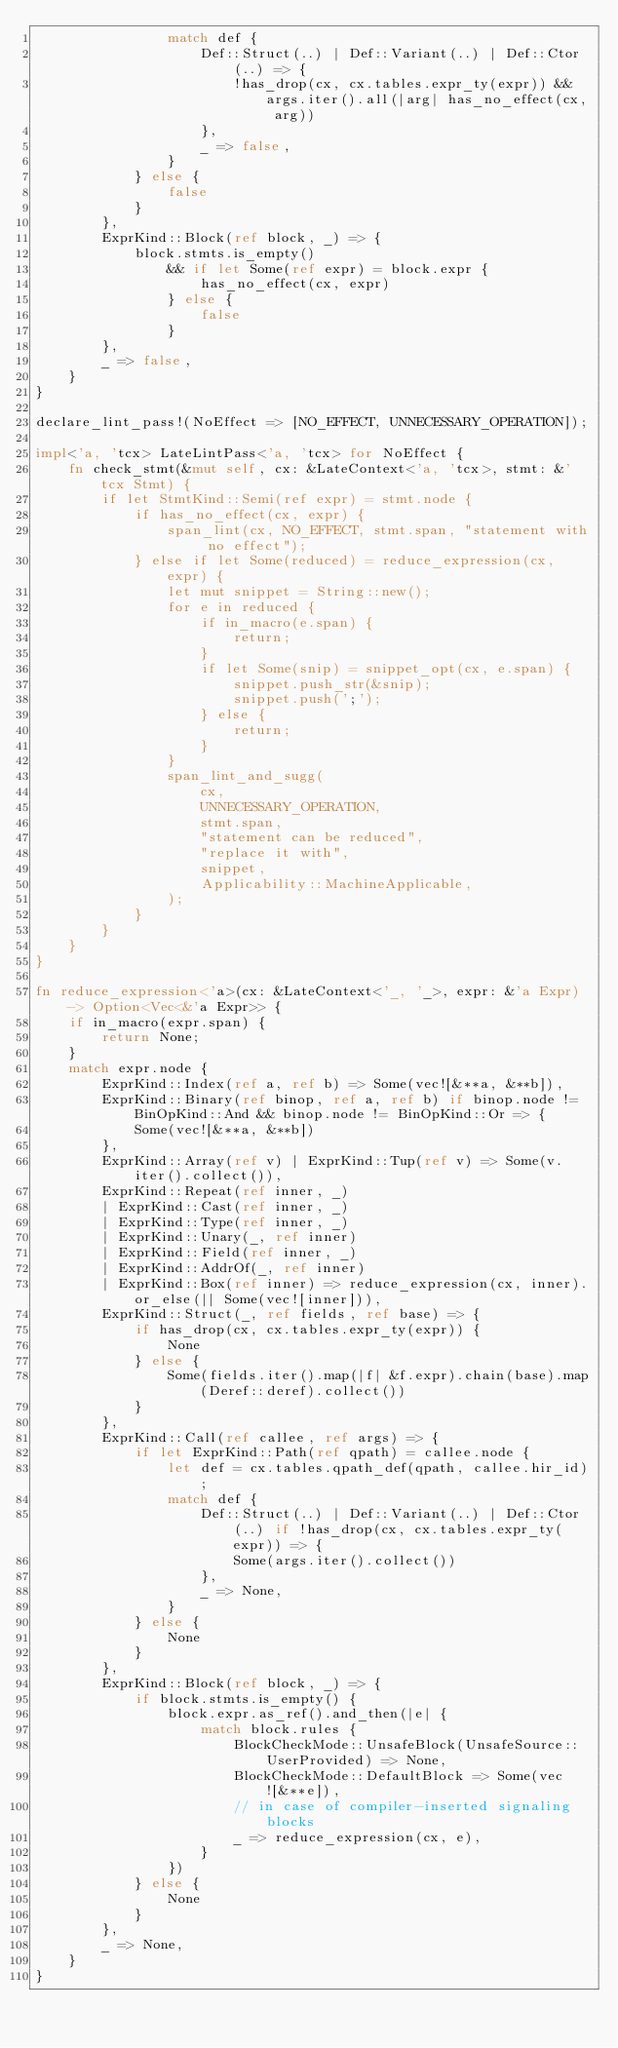<code> <loc_0><loc_0><loc_500><loc_500><_Rust_>                match def {
                    Def::Struct(..) | Def::Variant(..) | Def::Ctor(..) => {
                        !has_drop(cx, cx.tables.expr_ty(expr)) && args.iter().all(|arg| has_no_effect(cx, arg))
                    },
                    _ => false,
                }
            } else {
                false
            }
        },
        ExprKind::Block(ref block, _) => {
            block.stmts.is_empty()
                && if let Some(ref expr) = block.expr {
                    has_no_effect(cx, expr)
                } else {
                    false
                }
        },
        _ => false,
    }
}

declare_lint_pass!(NoEffect => [NO_EFFECT, UNNECESSARY_OPERATION]);

impl<'a, 'tcx> LateLintPass<'a, 'tcx> for NoEffect {
    fn check_stmt(&mut self, cx: &LateContext<'a, 'tcx>, stmt: &'tcx Stmt) {
        if let StmtKind::Semi(ref expr) = stmt.node {
            if has_no_effect(cx, expr) {
                span_lint(cx, NO_EFFECT, stmt.span, "statement with no effect");
            } else if let Some(reduced) = reduce_expression(cx, expr) {
                let mut snippet = String::new();
                for e in reduced {
                    if in_macro(e.span) {
                        return;
                    }
                    if let Some(snip) = snippet_opt(cx, e.span) {
                        snippet.push_str(&snip);
                        snippet.push(';');
                    } else {
                        return;
                    }
                }
                span_lint_and_sugg(
                    cx,
                    UNNECESSARY_OPERATION,
                    stmt.span,
                    "statement can be reduced",
                    "replace it with",
                    snippet,
                    Applicability::MachineApplicable,
                );
            }
        }
    }
}

fn reduce_expression<'a>(cx: &LateContext<'_, '_>, expr: &'a Expr) -> Option<Vec<&'a Expr>> {
    if in_macro(expr.span) {
        return None;
    }
    match expr.node {
        ExprKind::Index(ref a, ref b) => Some(vec![&**a, &**b]),
        ExprKind::Binary(ref binop, ref a, ref b) if binop.node != BinOpKind::And && binop.node != BinOpKind::Or => {
            Some(vec![&**a, &**b])
        },
        ExprKind::Array(ref v) | ExprKind::Tup(ref v) => Some(v.iter().collect()),
        ExprKind::Repeat(ref inner, _)
        | ExprKind::Cast(ref inner, _)
        | ExprKind::Type(ref inner, _)
        | ExprKind::Unary(_, ref inner)
        | ExprKind::Field(ref inner, _)
        | ExprKind::AddrOf(_, ref inner)
        | ExprKind::Box(ref inner) => reduce_expression(cx, inner).or_else(|| Some(vec![inner])),
        ExprKind::Struct(_, ref fields, ref base) => {
            if has_drop(cx, cx.tables.expr_ty(expr)) {
                None
            } else {
                Some(fields.iter().map(|f| &f.expr).chain(base).map(Deref::deref).collect())
            }
        },
        ExprKind::Call(ref callee, ref args) => {
            if let ExprKind::Path(ref qpath) = callee.node {
                let def = cx.tables.qpath_def(qpath, callee.hir_id);
                match def {
                    Def::Struct(..) | Def::Variant(..) | Def::Ctor(..) if !has_drop(cx, cx.tables.expr_ty(expr)) => {
                        Some(args.iter().collect())
                    },
                    _ => None,
                }
            } else {
                None
            }
        },
        ExprKind::Block(ref block, _) => {
            if block.stmts.is_empty() {
                block.expr.as_ref().and_then(|e| {
                    match block.rules {
                        BlockCheckMode::UnsafeBlock(UnsafeSource::UserProvided) => None,
                        BlockCheckMode::DefaultBlock => Some(vec![&**e]),
                        // in case of compiler-inserted signaling blocks
                        _ => reduce_expression(cx, e),
                    }
                })
            } else {
                None
            }
        },
        _ => None,
    }
}
</code> 